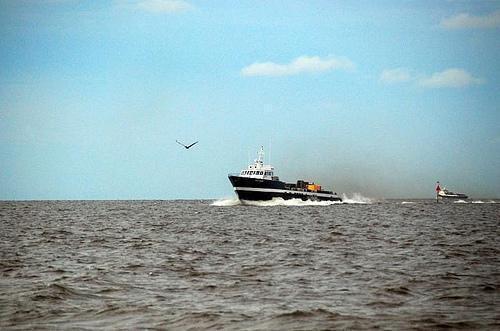What is the boat plowing through?
Indicate the correct response by choosing from the four available options to answer the question.
Options: Lake, ocean, canal, riverwater. Ocean. 